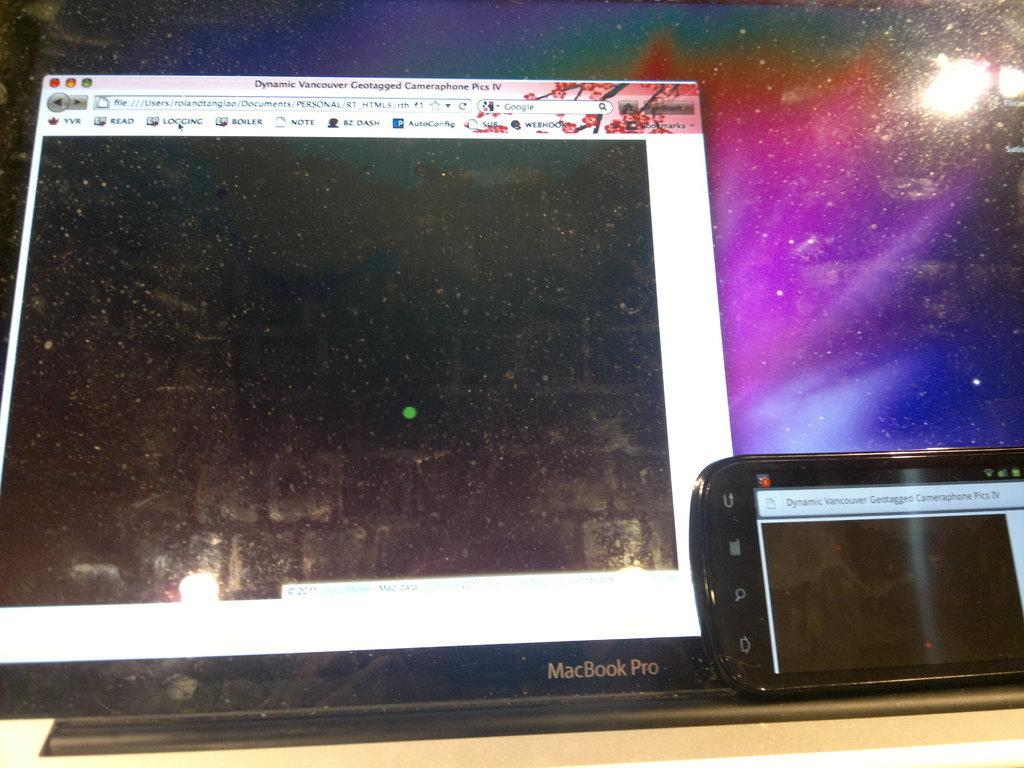<image>
Summarize the visual content of the image. A MacBook Pro with a phone on its screen. 